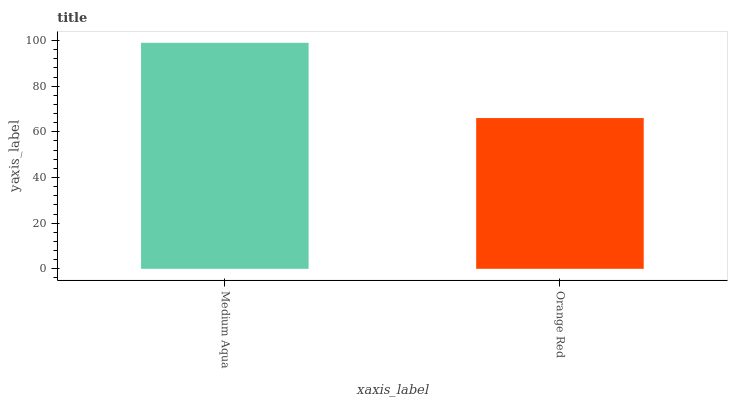Is Orange Red the maximum?
Answer yes or no. No. Is Medium Aqua greater than Orange Red?
Answer yes or no. Yes. Is Orange Red less than Medium Aqua?
Answer yes or no. Yes. Is Orange Red greater than Medium Aqua?
Answer yes or no. No. Is Medium Aqua less than Orange Red?
Answer yes or no. No. Is Medium Aqua the high median?
Answer yes or no. Yes. Is Orange Red the low median?
Answer yes or no. Yes. Is Orange Red the high median?
Answer yes or no. No. Is Medium Aqua the low median?
Answer yes or no. No. 